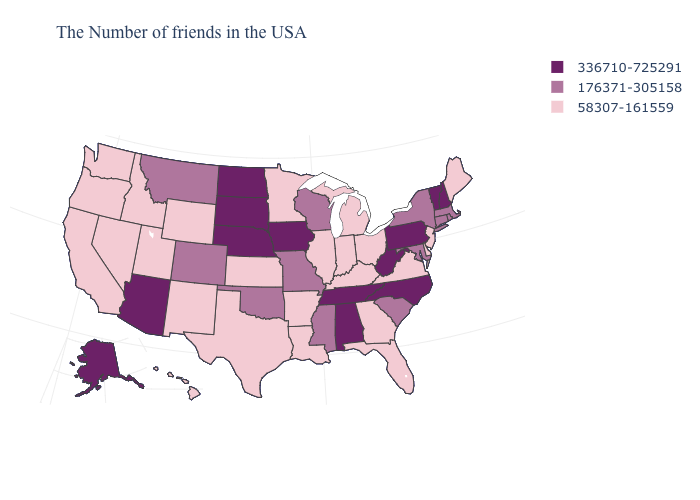Name the states that have a value in the range 176371-305158?
Give a very brief answer. Massachusetts, Rhode Island, Connecticut, New York, Maryland, South Carolina, Wisconsin, Mississippi, Missouri, Oklahoma, Colorado, Montana. What is the value of Indiana?
Quick response, please. 58307-161559. Does California have the same value as Kentucky?
Quick response, please. Yes. Does North Carolina have the highest value in the USA?
Keep it brief. Yes. Which states have the highest value in the USA?
Answer briefly. New Hampshire, Vermont, Pennsylvania, North Carolina, West Virginia, Alabama, Tennessee, Iowa, Nebraska, South Dakota, North Dakota, Arizona, Alaska. Which states hav the highest value in the MidWest?
Quick response, please. Iowa, Nebraska, South Dakota, North Dakota. What is the lowest value in states that border Kentucky?
Give a very brief answer. 58307-161559. Is the legend a continuous bar?
Answer briefly. No. Name the states that have a value in the range 176371-305158?
Concise answer only. Massachusetts, Rhode Island, Connecticut, New York, Maryland, South Carolina, Wisconsin, Mississippi, Missouri, Oklahoma, Colorado, Montana. Which states have the lowest value in the USA?
Quick response, please. Maine, New Jersey, Delaware, Virginia, Ohio, Florida, Georgia, Michigan, Kentucky, Indiana, Illinois, Louisiana, Arkansas, Minnesota, Kansas, Texas, Wyoming, New Mexico, Utah, Idaho, Nevada, California, Washington, Oregon, Hawaii. Which states have the lowest value in the USA?
Give a very brief answer. Maine, New Jersey, Delaware, Virginia, Ohio, Florida, Georgia, Michigan, Kentucky, Indiana, Illinois, Louisiana, Arkansas, Minnesota, Kansas, Texas, Wyoming, New Mexico, Utah, Idaho, Nevada, California, Washington, Oregon, Hawaii. What is the lowest value in states that border California?
Short answer required. 58307-161559. Which states have the lowest value in the MidWest?
Write a very short answer. Ohio, Michigan, Indiana, Illinois, Minnesota, Kansas. What is the highest value in the USA?
Give a very brief answer. 336710-725291. Name the states that have a value in the range 336710-725291?
Quick response, please. New Hampshire, Vermont, Pennsylvania, North Carolina, West Virginia, Alabama, Tennessee, Iowa, Nebraska, South Dakota, North Dakota, Arizona, Alaska. 